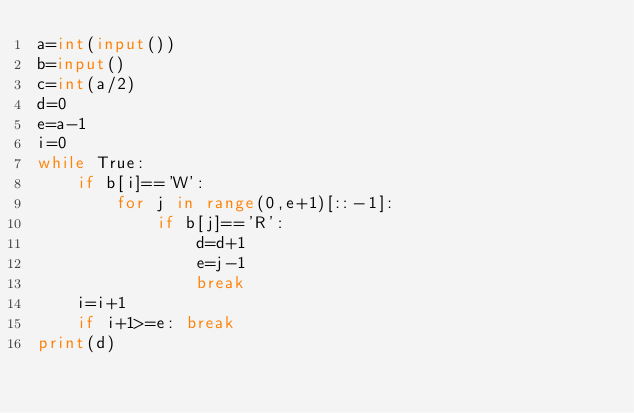<code> <loc_0><loc_0><loc_500><loc_500><_Python_>a=int(input())
b=input()
c=int(a/2)
d=0
e=a-1
i=0
while True:
    if b[i]=='W':
        for j in range(0,e+1)[::-1]:
            if b[j]=='R':
                d=d+1
                e=j-1
                break
    i=i+1
    if i+1>=e: break
print(d)</code> 